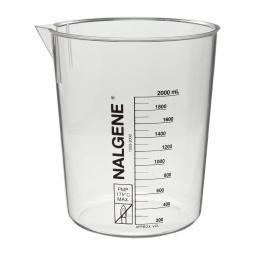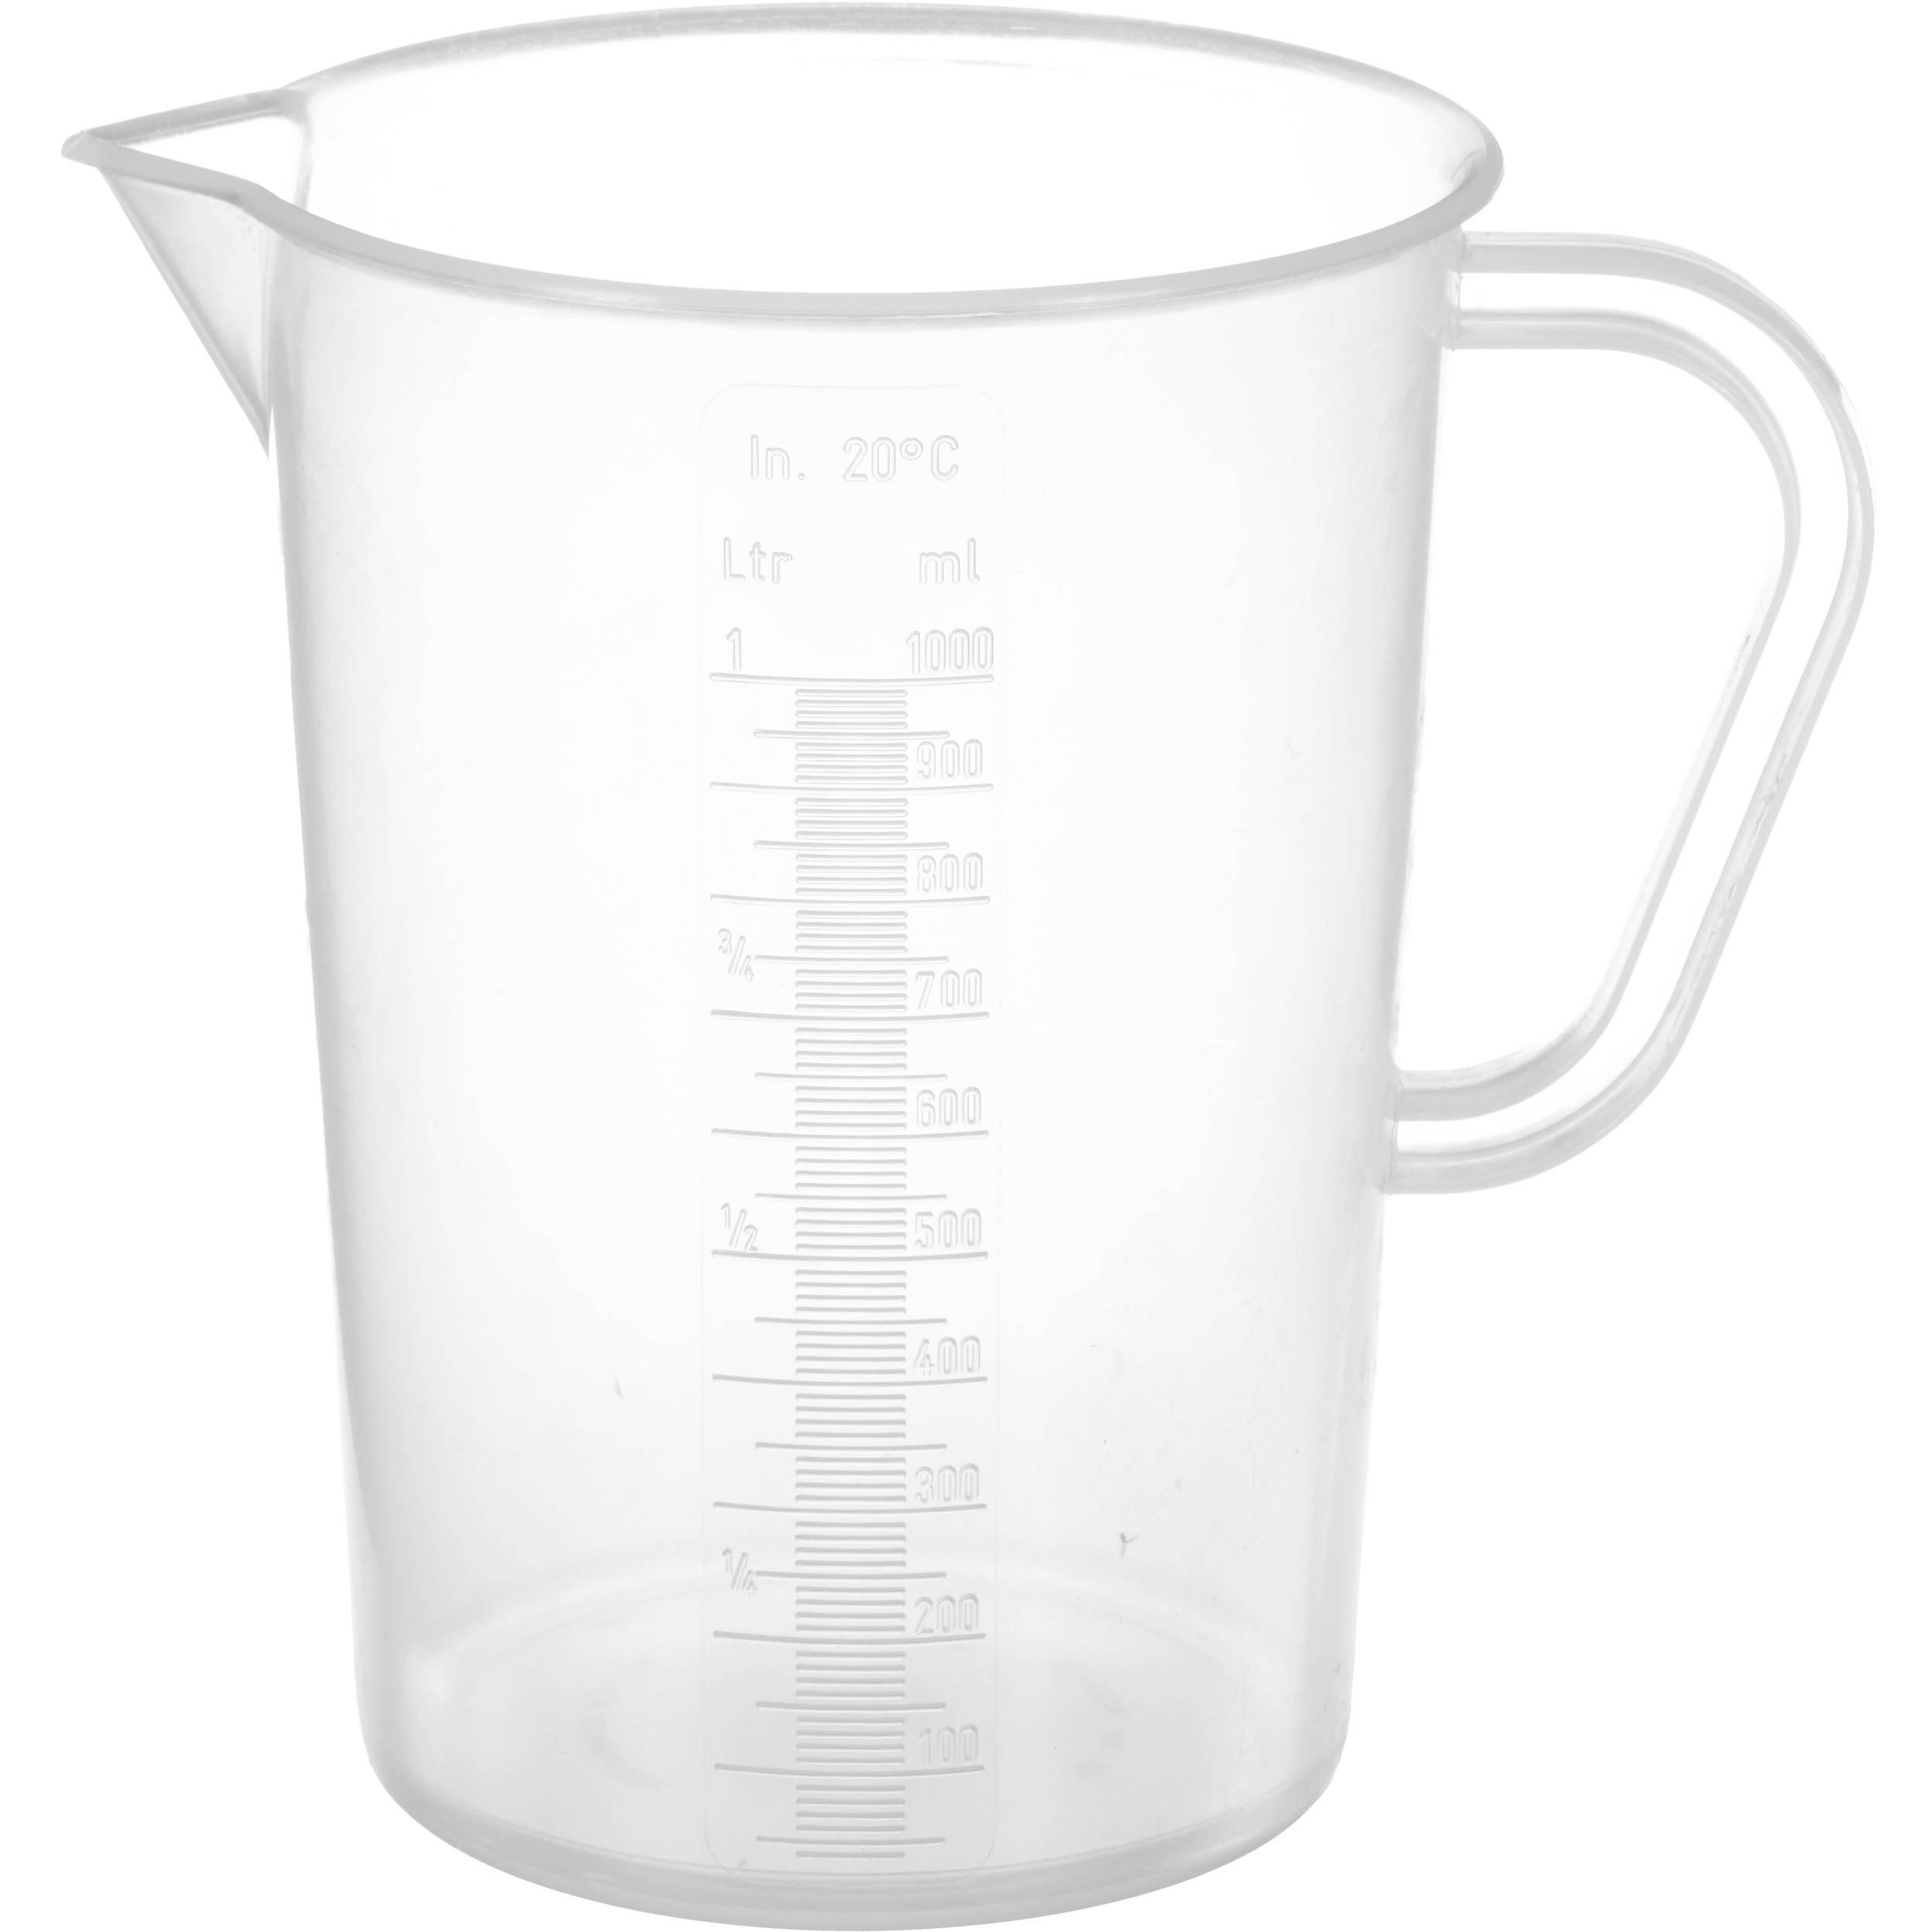The first image is the image on the left, the second image is the image on the right. Considering the images on both sides, is "The left and right image contains the same number of beakers with at least one with a handle." valid? Answer yes or no. Yes. The first image is the image on the left, the second image is the image on the right. Examine the images to the left and right. Is the description "The measuring cup in one of the pictures has black writing and markings on it." accurate? Answer yes or no. Yes. 